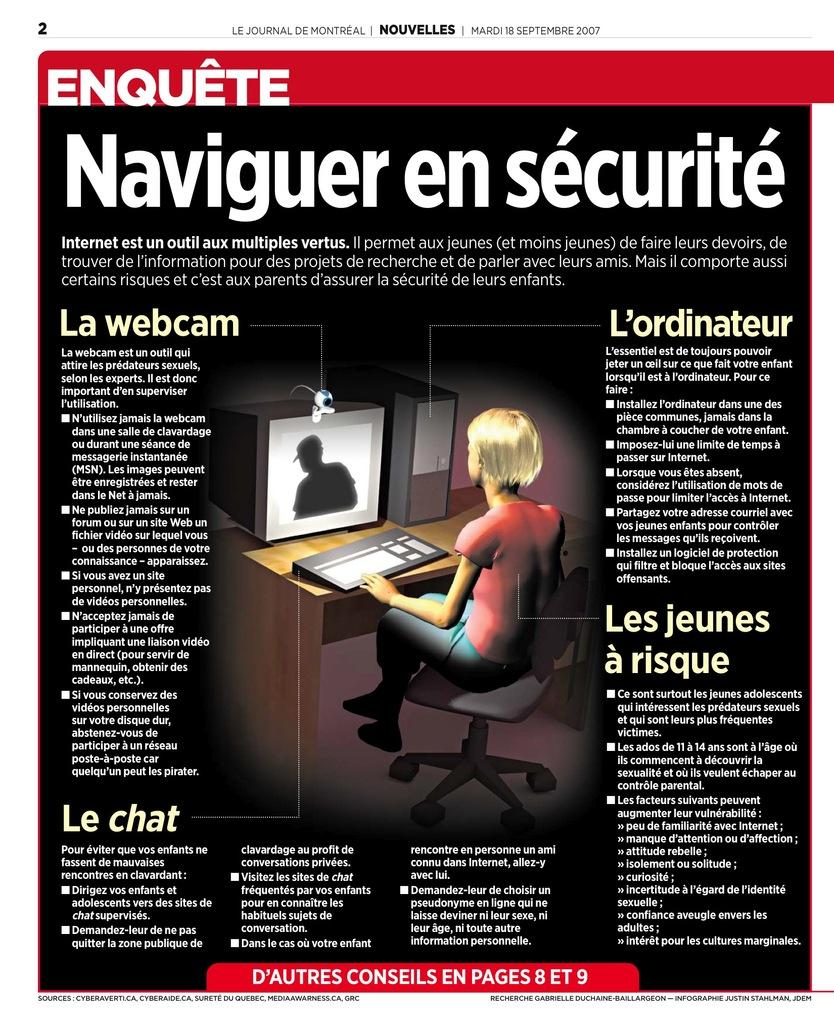What is the person in the image doing? The person is sitting on a chair in the image. What can be seen on the table in the image? There is a system (computer) on the table, along with a keyboard and a CPU. What is the poster in the image like? The poster has writing on it in black and red colors. Can you see any fish swimming in the image? No, there are no fish present in the image. Is the person in the image being held in a prison? No, there is no indication of a prison or any confinement in the image. 